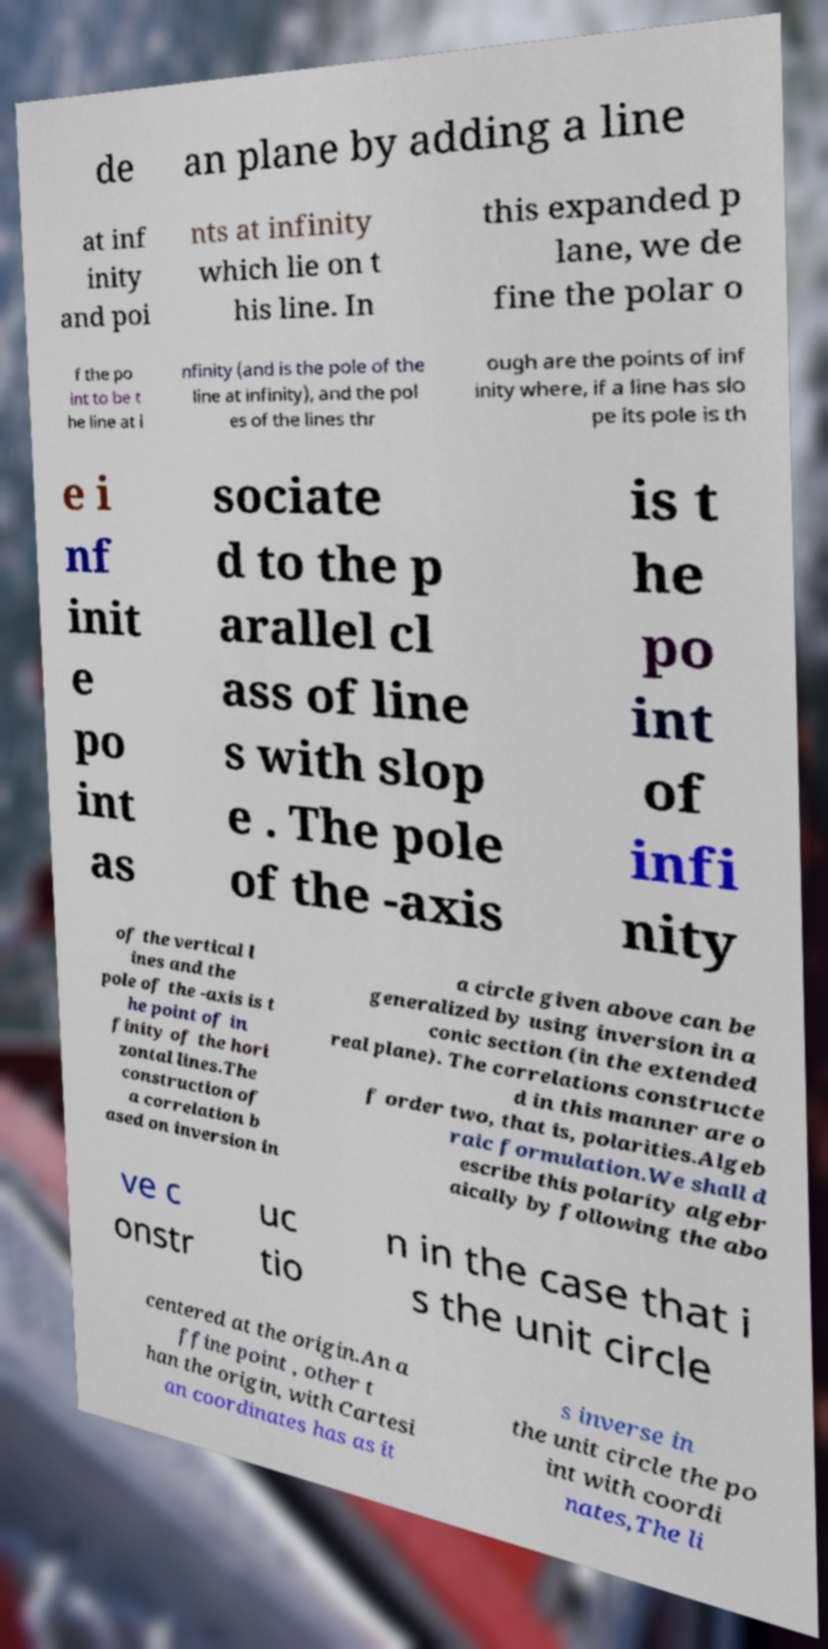Please identify and transcribe the text found in this image. de an plane by adding a line at inf inity and poi nts at infinity which lie on t his line. In this expanded p lane, we de fine the polar o f the po int to be t he line at i nfinity (and is the pole of the line at infinity), and the pol es of the lines thr ough are the points of inf inity where, if a line has slo pe its pole is th e i nf init e po int as sociate d to the p arallel cl ass of line s with slop e . The pole of the -axis is t he po int of infi nity of the vertical l ines and the pole of the -axis is t he point of in finity of the hori zontal lines.The construction of a correlation b ased on inversion in a circle given above can be generalized by using inversion in a conic section (in the extended real plane). The correlations constructe d in this manner are o f order two, that is, polarities.Algeb raic formulation.We shall d escribe this polarity algebr aically by following the abo ve c onstr uc tio n in the case that i s the unit circle centered at the origin.An a ffine point , other t han the origin, with Cartesi an coordinates has as it s inverse in the unit circle the po int with coordi nates,The li 